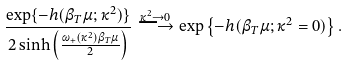<formula> <loc_0><loc_0><loc_500><loc_500>\frac { \exp \{ - h ( \beta _ { T } \mu ; \kappa ^ { 2 } ) \} } { 2 \sinh \left ( \frac { \omega _ { + } ( \kappa ^ { 2 } ) \beta _ { T } \mu } { 2 } \right ) } \stackrel { \kappa ^ { 2 } \rightarrow 0 } { \longrightarrow } \exp \left \{ - h ( \beta _ { T } \mu ; \kappa ^ { 2 } = 0 ) \right \} .</formula> 